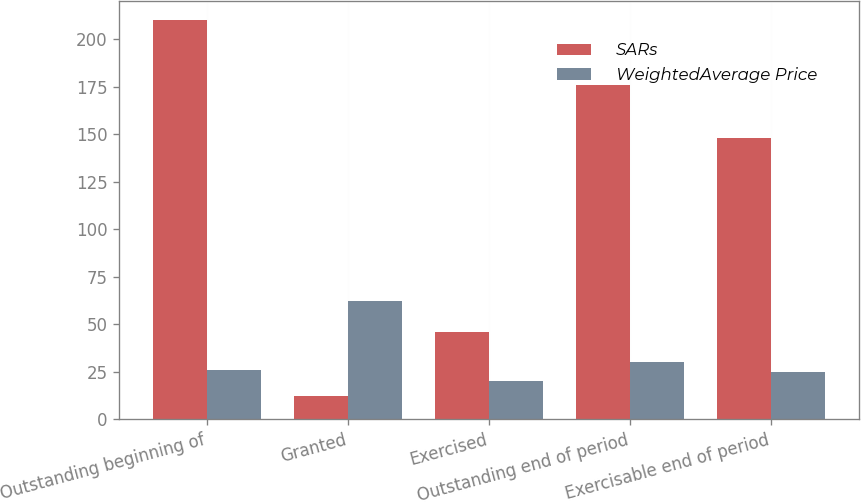Convert chart to OTSL. <chart><loc_0><loc_0><loc_500><loc_500><stacked_bar_chart><ecel><fcel>Outstanding beginning of<fcel>Granted<fcel>Exercised<fcel>Outstanding end of period<fcel>Exercisable end of period<nl><fcel>SARs<fcel>210<fcel>12<fcel>46<fcel>176<fcel>148<nl><fcel>WeightedAverage Price<fcel>26<fcel>62<fcel>20<fcel>30<fcel>25<nl></chart> 